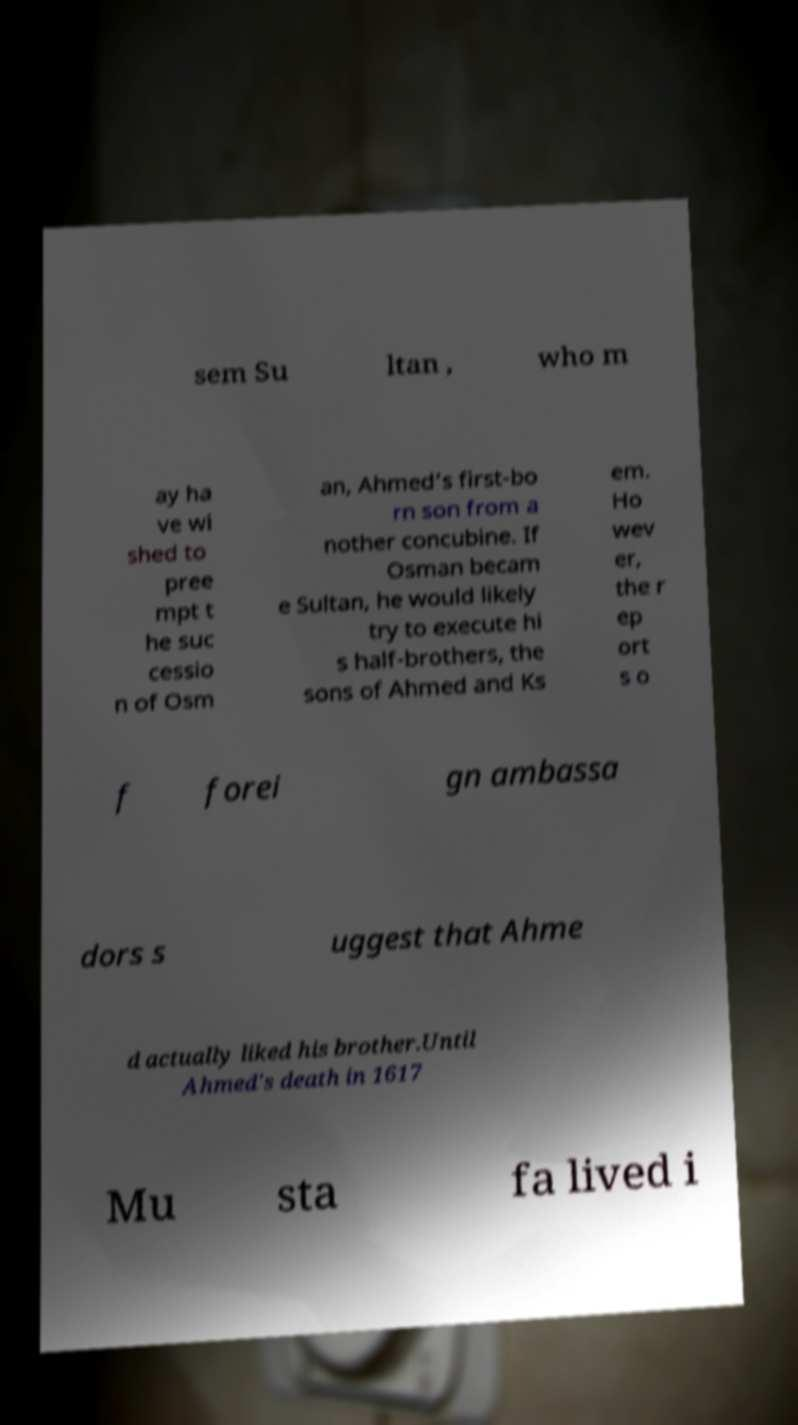Could you assist in decoding the text presented in this image and type it out clearly? sem Su ltan , who m ay ha ve wi shed to pree mpt t he suc cessio n of Osm an, Ahmed’s first-bo rn son from a nother concubine. If Osman becam e Sultan, he would likely try to execute hi s half-brothers, the sons of Ahmed and Ks em. Ho wev er, the r ep ort s o f forei gn ambassa dors s uggest that Ahme d actually liked his brother.Until Ahmed's death in 1617 Mu sta fa lived i 